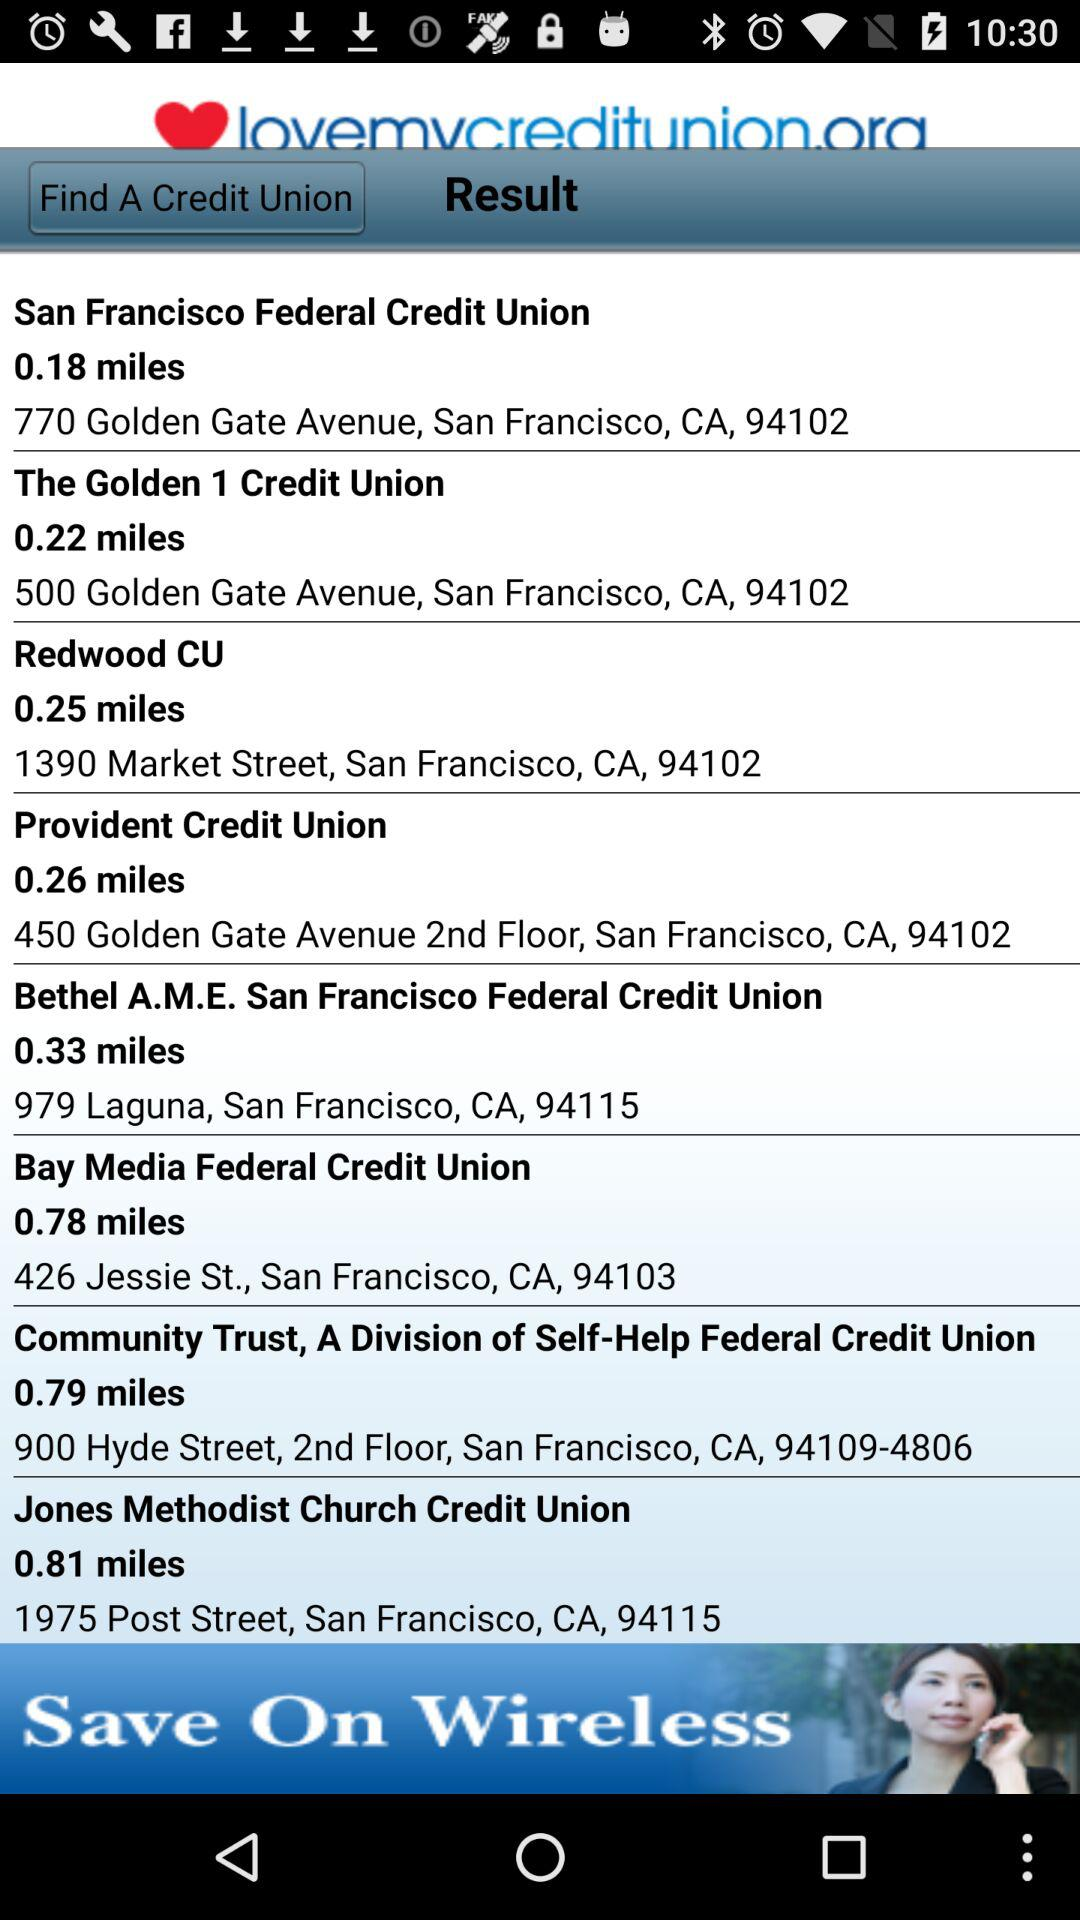What is the location of "Jones Methodist Church Credit Union"? The location of "Jones Methodist Church Credit Union" is 1975 Post Street, San Francisco, CA, 94115. 